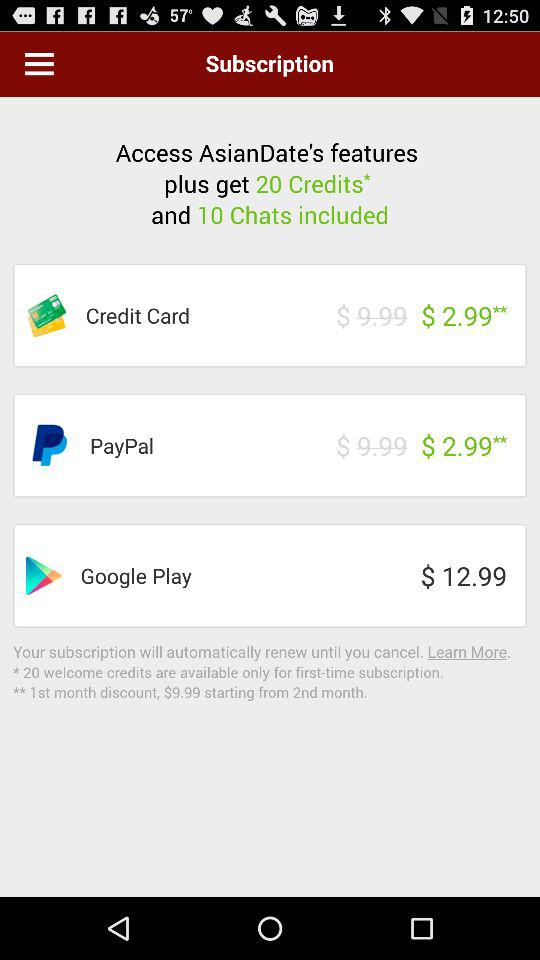How many chats are included? There are 10 chats included. 